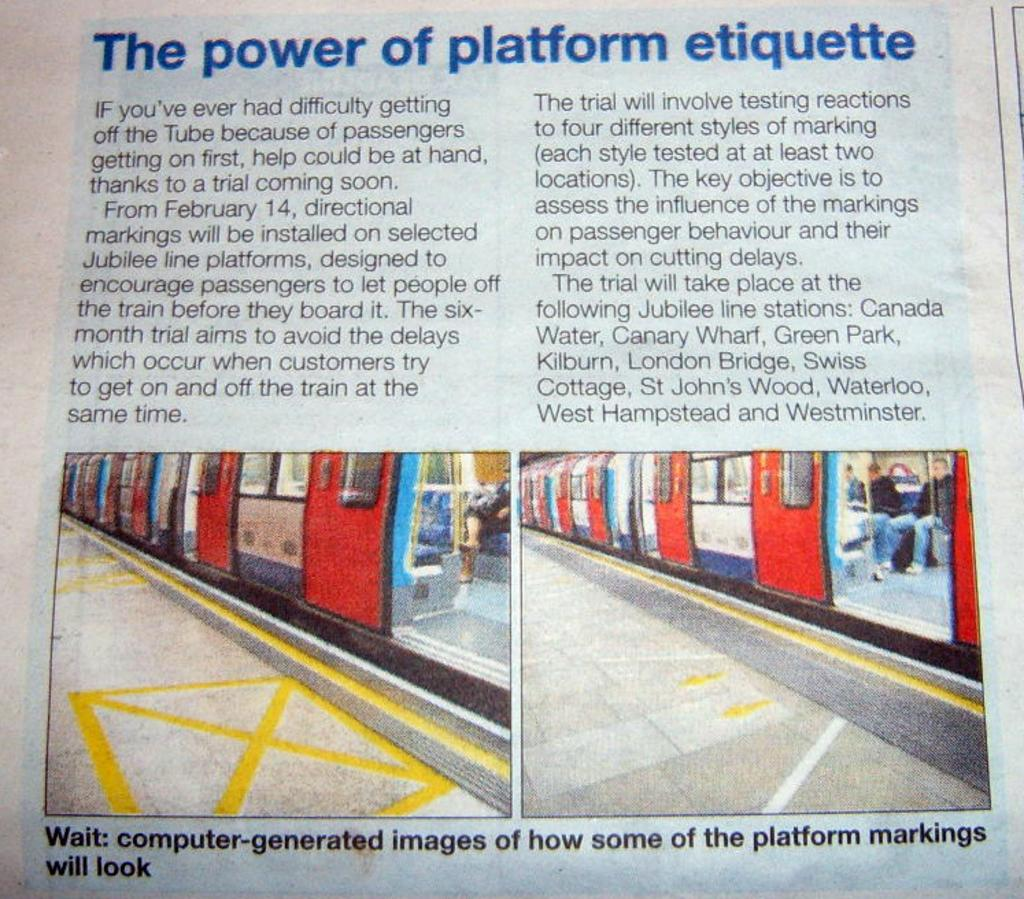What type of publication is visible in the image? There is a magazine in the image. What can be found on the pages of the magazine? There is text in the image. How many photos are included in the magazine? There are two photos in the image. What is depicted in the photos? The photos contain trains with windows. Are there any people visible in the image? Yes, there are people visible in the image. What type of structures can be seen in the image? There are platforms in the image. What type of education is being offered at the station in the image? There is no station present in the image, and therefore no education being offered. What type of scene is depicted in the image? The image contains a magazine with photos of trains and platforms, but it does not depict a specific scene. 